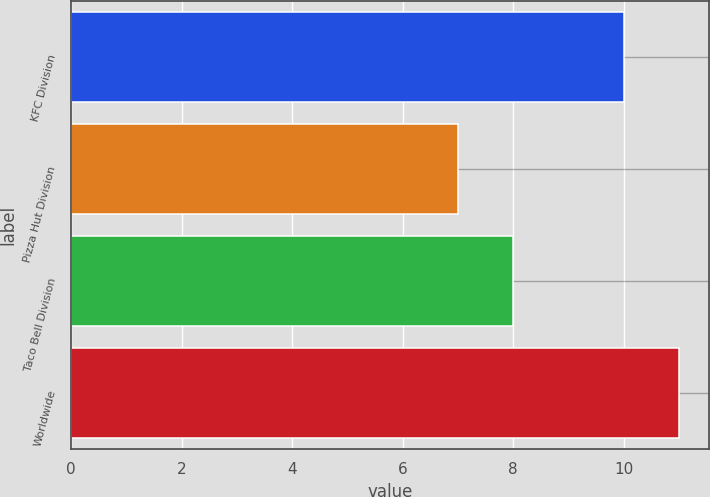Convert chart to OTSL. <chart><loc_0><loc_0><loc_500><loc_500><bar_chart><fcel>KFC Division<fcel>Pizza Hut Division<fcel>Taco Bell Division<fcel>Worldwide<nl><fcel>10<fcel>7<fcel>8<fcel>11<nl></chart> 